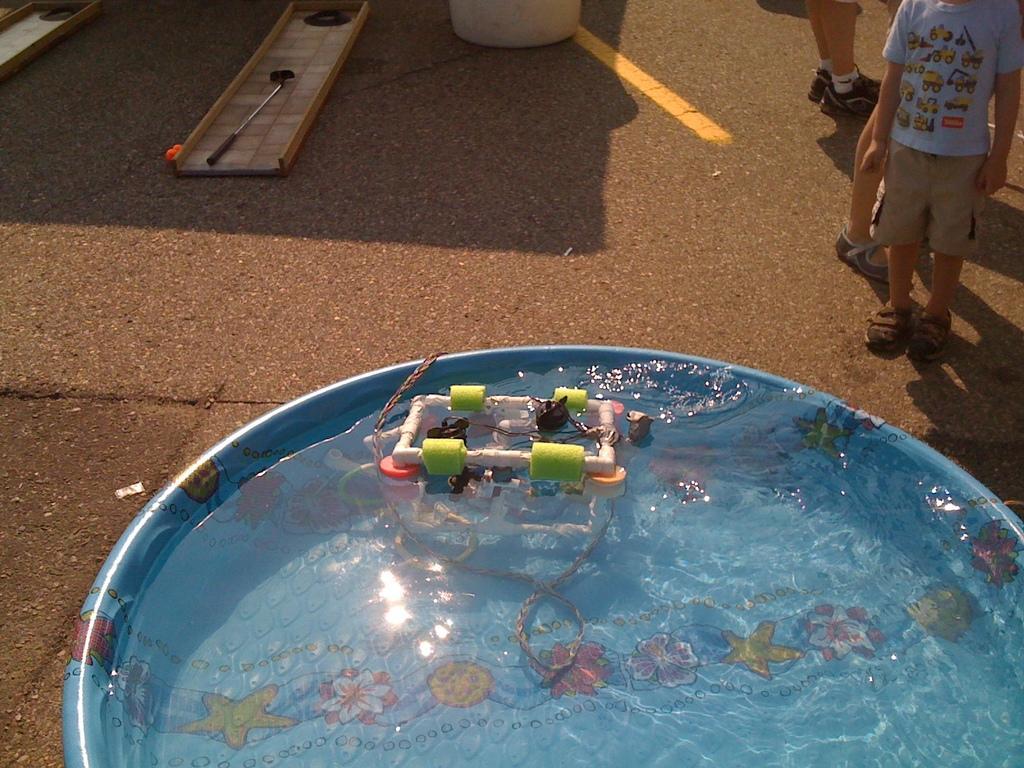Please provide a concise description of this image. In the center of the image we can see one tub. In the tub, we can see water and one colorful object in the water. In the background, we can see wooden objects, one screwdriver, one kid, human legs and a few other objects. 